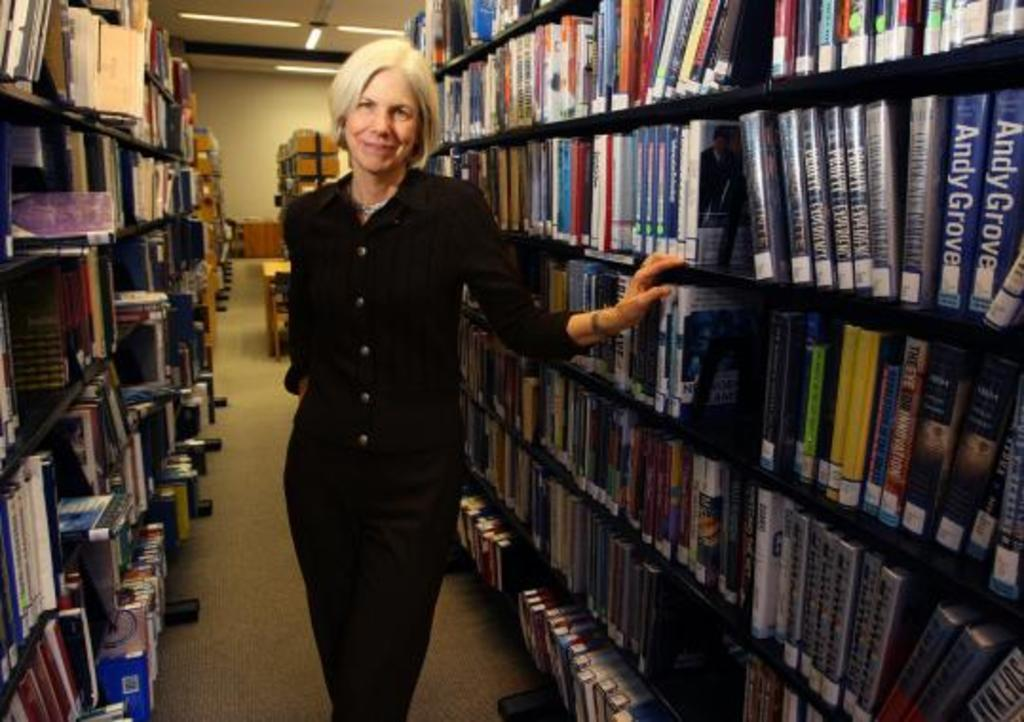Who is present in the image? There is a woman in the image. What is the woman doing in the image? The woman is standing in the image. What is the woman's facial expression in the image? The woman is smiling in the image. What can be seen on the shelves in the image? There are books on the shelves in the image. What type of thread is being used by the worm in the image? There is no worm or thread present in the image. What kind of apparatus is being used by the woman in the image? The image does not show any apparatus being used by the woman. 